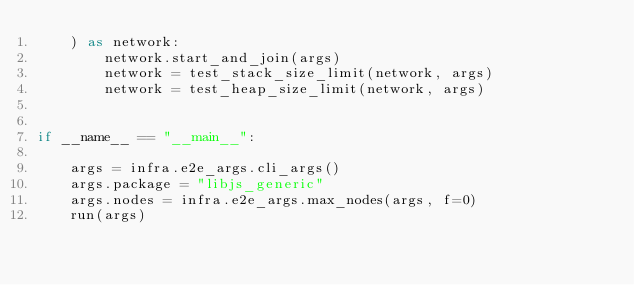<code> <loc_0><loc_0><loc_500><loc_500><_Python_>    ) as network:
        network.start_and_join(args)
        network = test_stack_size_limit(network, args)
        network = test_heap_size_limit(network, args)


if __name__ == "__main__":

    args = infra.e2e_args.cli_args()
    args.package = "libjs_generic"
    args.nodes = infra.e2e_args.max_nodes(args, f=0)
    run(args)
</code> 